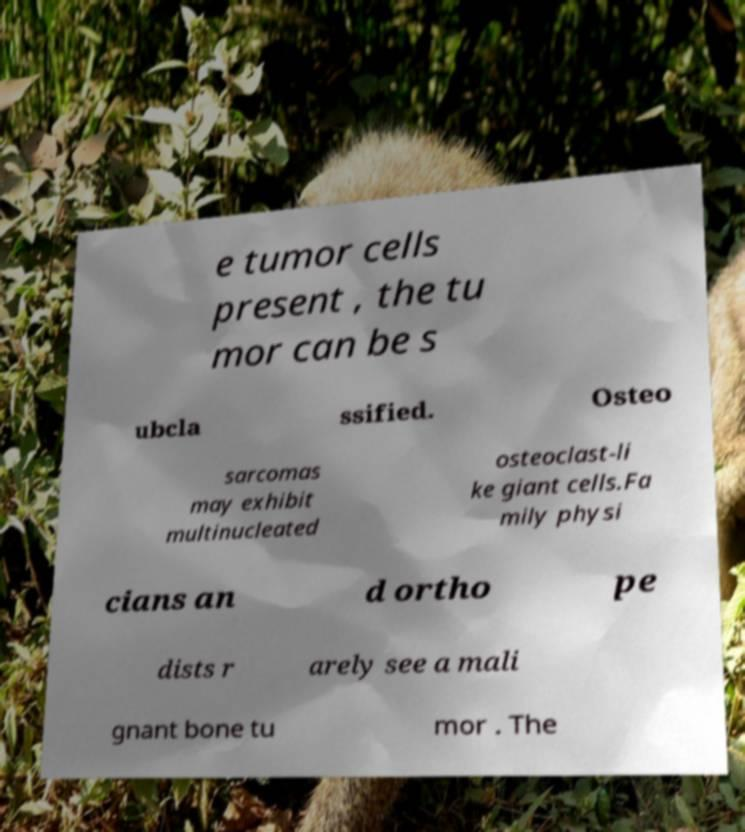There's text embedded in this image that I need extracted. Can you transcribe it verbatim? e tumor cells present , the tu mor can be s ubcla ssified. Osteo sarcomas may exhibit multinucleated osteoclast-li ke giant cells.Fa mily physi cians an d ortho pe dists r arely see a mali gnant bone tu mor . The 